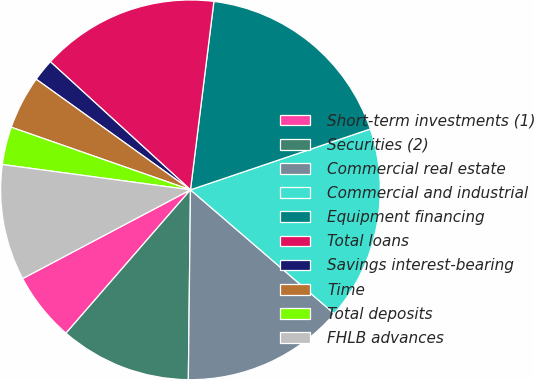Convert chart. <chart><loc_0><loc_0><loc_500><loc_500><pie_chart><fcel>Short-term investments (1)<fcel>Securities (2)<fcel>Commercial real estate<fcel>Commercial and industrial<fcel>Equipment financing<fcel>Total loans<fcel>Savings interest-bearing<fcel>Time<fcel>Total deposits<fcel>FHLB advances<nl><fcel>5.88%<fcel>11.2%<fcel>13.86%<fcel>16.51%<fcel>17.84%<fcel>15.18%<fcel>1.89%<fcel>4.55%<fcel>3.22%<fcel>9.87%<nl></chart> 